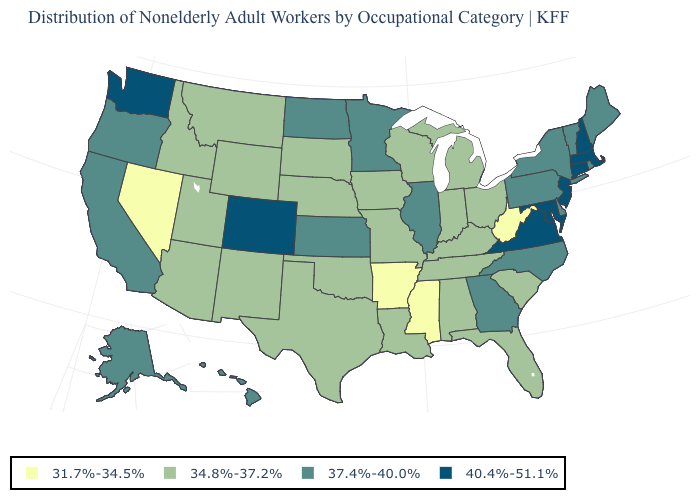Name the states that have a value in the range 34.8%-37.2%?
Keep it brief. Alabama, Arizona, Florida, Idaho, Indiana, Iowa, Kentucky, Louisiana, Michigan, Missouri, Montana, Nebraska, New Mexico, Ohio, Oklahoma, South Carolina, South Dakota, Tennessee, Texas, Utah, Wisconsin, Wyoming. What is the value of Massachusetts?
Answer briefly. 40.4%-51.1%. How many symbols are there in the legend?
Be succinct. 4. What is the value of Georgia?
Keep it brief. 37.4%-40.0%. Among the states that border North Dakota , which have the highest value?
Keep it brief. Minnesota. What is the value of South Carolina?
Quick response, please. 34.8%-37.2%. Name the states that have a value in the range 37.4%-40.0%?
Short answer required. Alaska, California, Delaware, Georgia, Hawaii, Illinois, Kansas, Maine, Minnesota, New York, North Carolina, North Dakota, Oregon, Pennsylvania, Rhode Island, Vermont. What is the highest value in the MidWest ?
Be succinct. 37.4%-40.0%. What is the lowest value in the South?
Write a very short answer. 31.7%-34.5%. Name the states that have a value in the range 34.8%-37.2%?
Write a very short answer. Alabama, Arizona, Florida, Idaho, Indiana, Iowa, Kentucky, Louisiana, Michigan, Missouri, Montana, Nebraska, New Mexico, Ohio, Oklahoma, South Carolina, South Dakota, Tennessee, Texas, Utah, Wisconsin, Wyoming. Does Connecticut have the highest value in the USA?
Quick response, please. Yes. What is the highest value in the MidWest ?
Write a very short answer. 37.4%-40.0%. How many symbols are there in the legend?
Quick response, please. 4. What is the value of Ohio?
Be succinct. 34.8%-37.2%. 